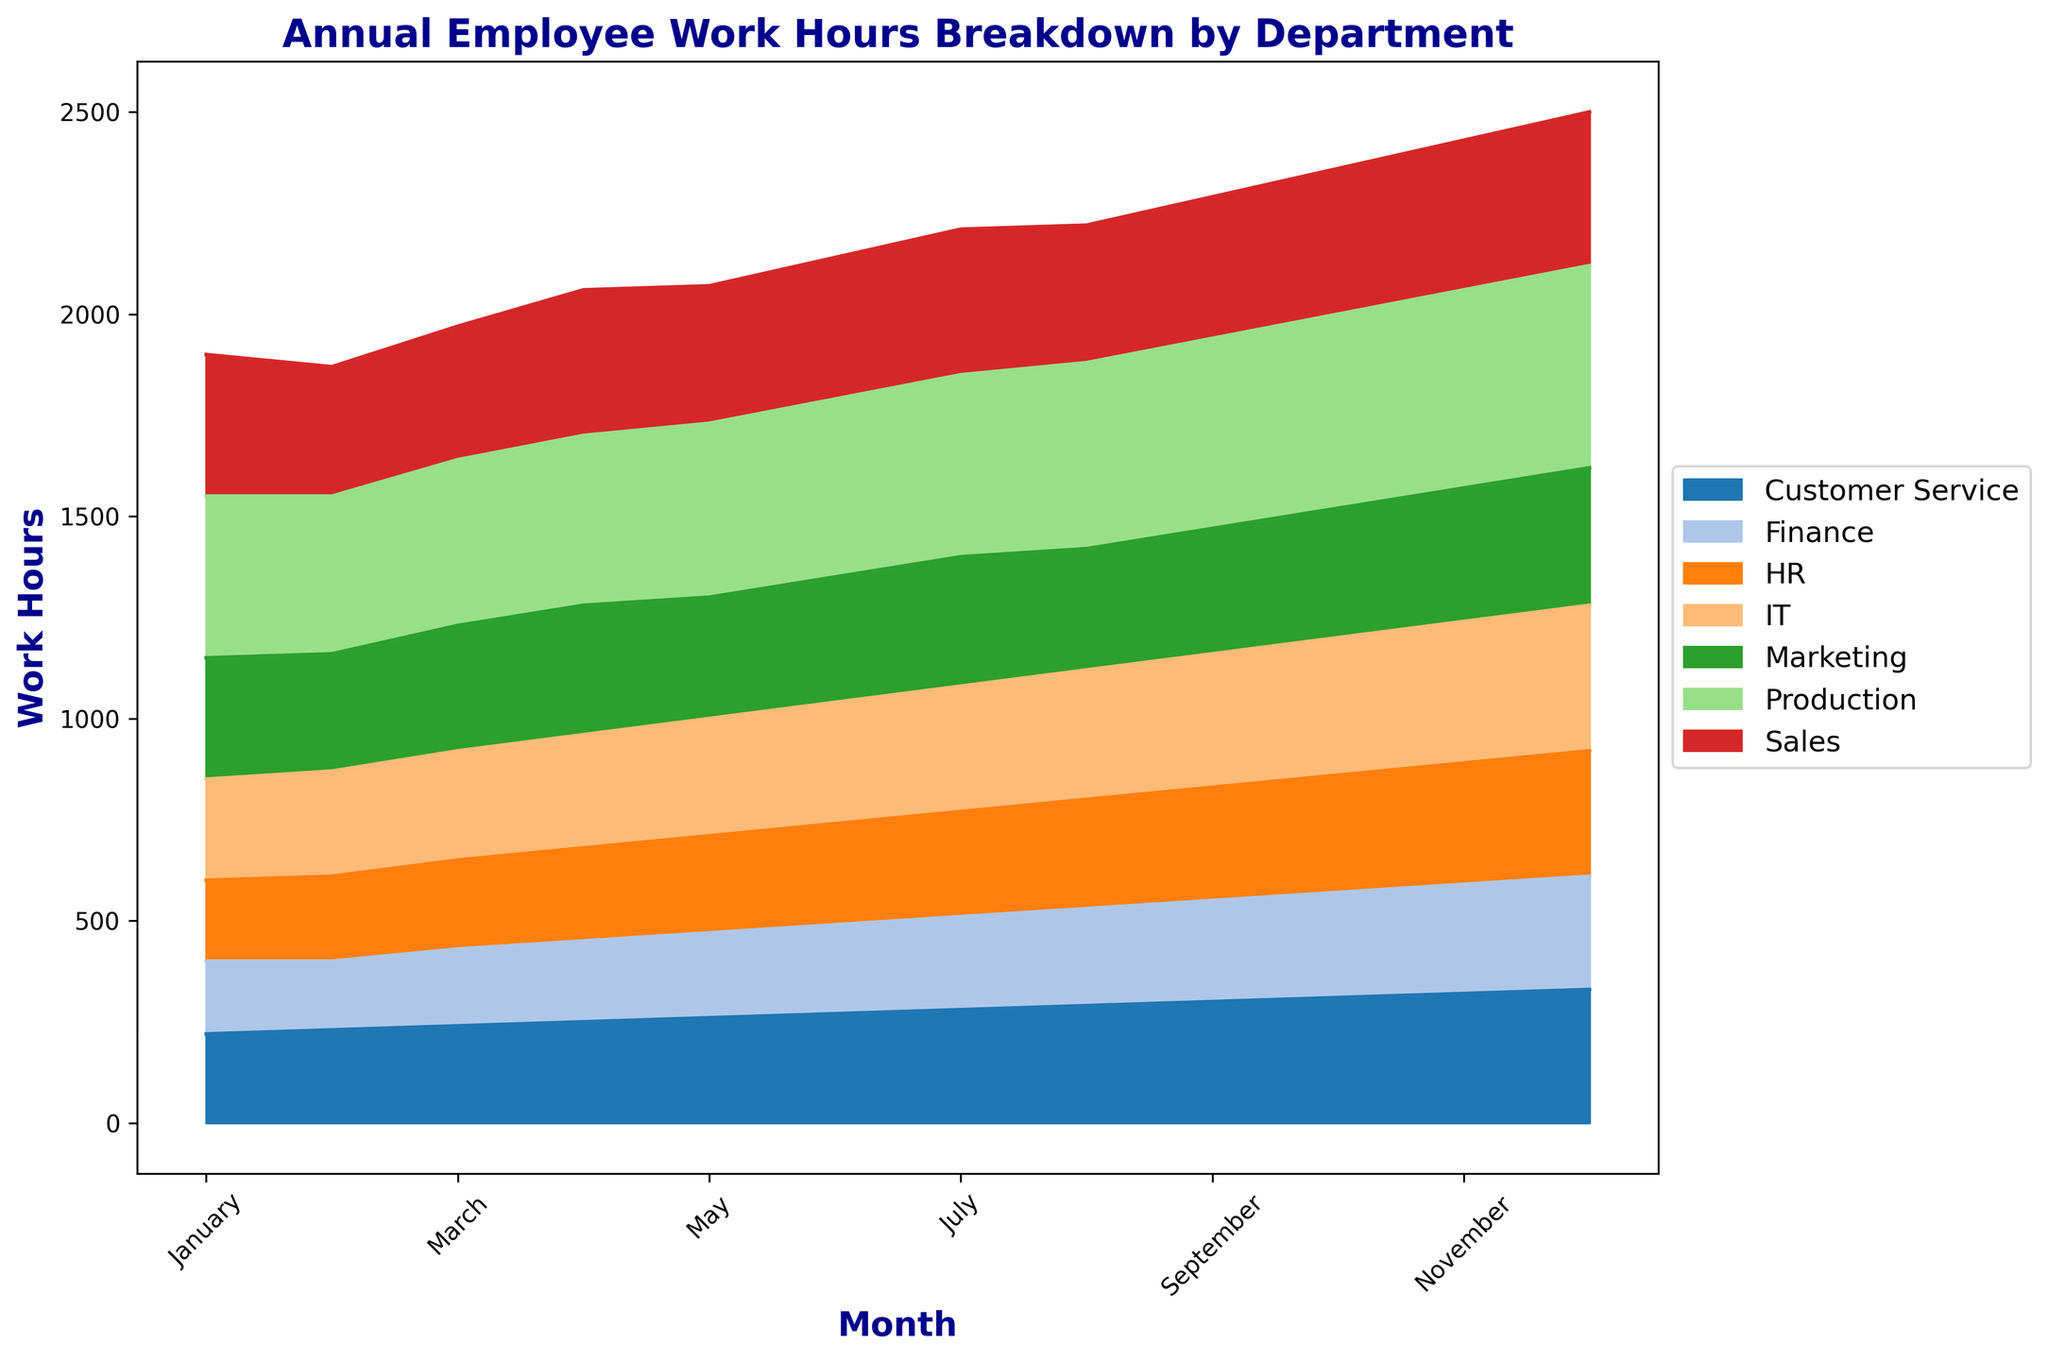What's the department with the highest total work hours over the year? To determine this, observe the area chart and visually estimate the department with the largest cumulative area. Production has the highest total area, indicating the highest total work hours over the year.
Answer: Production In which month did HR have the highest work hours? Look at the area representing HR in the plot for each month and identify the month where this area is the tallest. HR's work hours are tallest in December.
Answer: December Compare Sales and Marketing work hours in June. Which department had more work hours? Find the areas for Sales and Marketing in the month of June on the plot and compare their heights. Sales has a larger area in June compared to Marketing.
Answer: Sales What is the total work hours for IT in the first quarter (January to March)? Add the work hours for IT in January, February, and March: 250 + 260 + 270 = 780.
Answer: 780 Was there any month where Finance had less than 200 work hours? Look for the smallest areas representing Finance in each month and check their corresponding work hours. January and February show areas corresponding to 180 and 170 work hours, both less than 200.
Answer: Yes By how much did Production's work hours increase from September to December? Identify the work hours for Production in September and December: 470 and 500 respectively. Subtract September's number from December's: 500 - 470 = 30.
Answer: 30 Which month showed the highest overall work hours across all departments combined? Summing up the heights of all areas for each month visually, December appears to have the tallest combined height.
Answer: December Compare Customer Service work hours from January to July. How consistent are the monthly work hours? Observe the visual consistency of the heights of Customer Service areas from January to July. They display gradual increment, suggesting relatively consistent but growing work hours.
Answer: Relatively consistent Which two months had the largest difference in work hours for HR, and what was the difference? Visually check the tallest and shortest HR areas. Comparing December and January shows a substantial difference: 310 (December) - 200 (January) = 110.
Answer: January to December, 110 Calculate the average monthly work hours for Marketing over the year. Sum all monthly work hours for Marketing and divide by 12: (300 + 290 + 310 + 320 + 300 + 310 + 320 + 300 + 310 + 320 + 330 + 340) / 12 = 315.
Answer: 315 